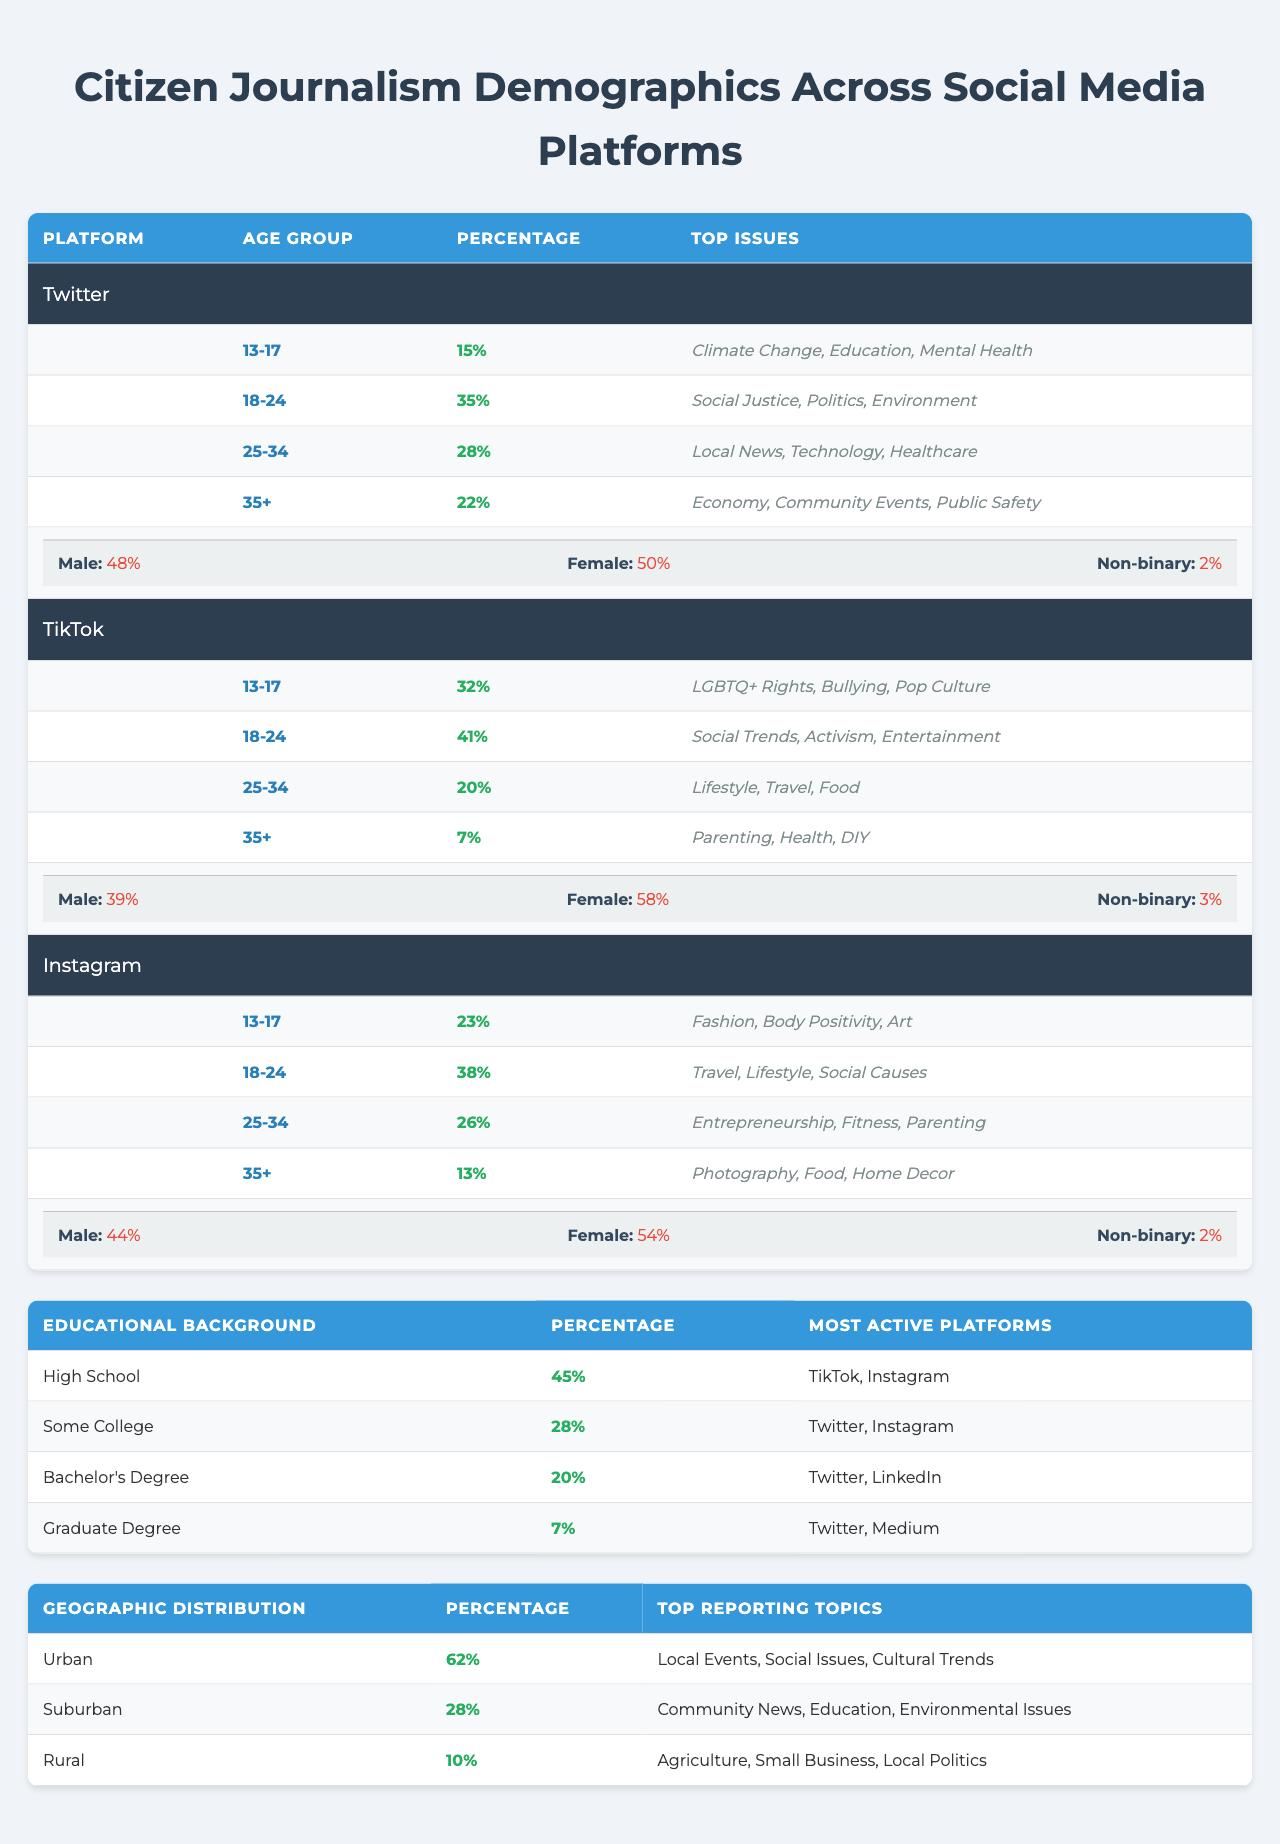What percentage of citizen journalists on Twitter are aged 18-24? According to the data, 35% of the citizen journalists on Twitter belong to the age group 18-24.
Answer: 35% Which social media platform has the highest percentage of citizen journalists aged 13-17? On examination of the age groups across the platforms, TikTok has the highest percentage at 32%.
Answer: TikTok What are the top issues reported by citizen journalists aged 25-34 on Instagram? The data specifies that the top issues for this age group on Instagram are Entrepreneurship, Fitness, and Parenting.
Answer: Entrepreneurship, Fitness, Parenting Is the gender distribution on TikTok more skewed towards female or male citizen journalists? The gender distribution shows 58% female and 39% male, indicating TikTok is more skewed towards female citizen journalists.
Answer: Yes What is the total percentage of citizen journalists aged 35+ across all three platforms? The percentages for age group 35+ are: Twitter (22%), TikTok (7%), and Instagram (13%), summing them gives 22 + 7 + 13 = 42%.
Answer: 42% Which age group on Twitter has the least representation, and what is its percentage? The group 13-17 has the least representation on Twitter at 15%.
Answer: 13-17, 15% What is the percentage of citizen journalists with a Graduate Degree that predominantly use which platforms? Only 7% of citizen journalists have a Graduate Degree, most active on Twitter and Medium.
Answer: 7%, Twitter, Medium How many total platforms report percentages for High School graduates, and which two platforms are they? The data indicates two platforms: TikTok and Instagram report High School graduates are the most active users, accounting for 45%.
Answer: 2, TikTok, Instagram What is the main issue reported by urban-dwelling citizen journalists? Urban citizen journalists primarily report on Local Events, Social Issues, and Cultural Trends, as indicated by their top topics.
Answer: Local Events, Social Issues, Cultural Trends What proportion of citizen journalists in suburban areas focuses on community news? The data states that 28% of citizen journalists are in suburban regions, focusing on community news along with Education and Environmental Issues.
Answer: 28% 